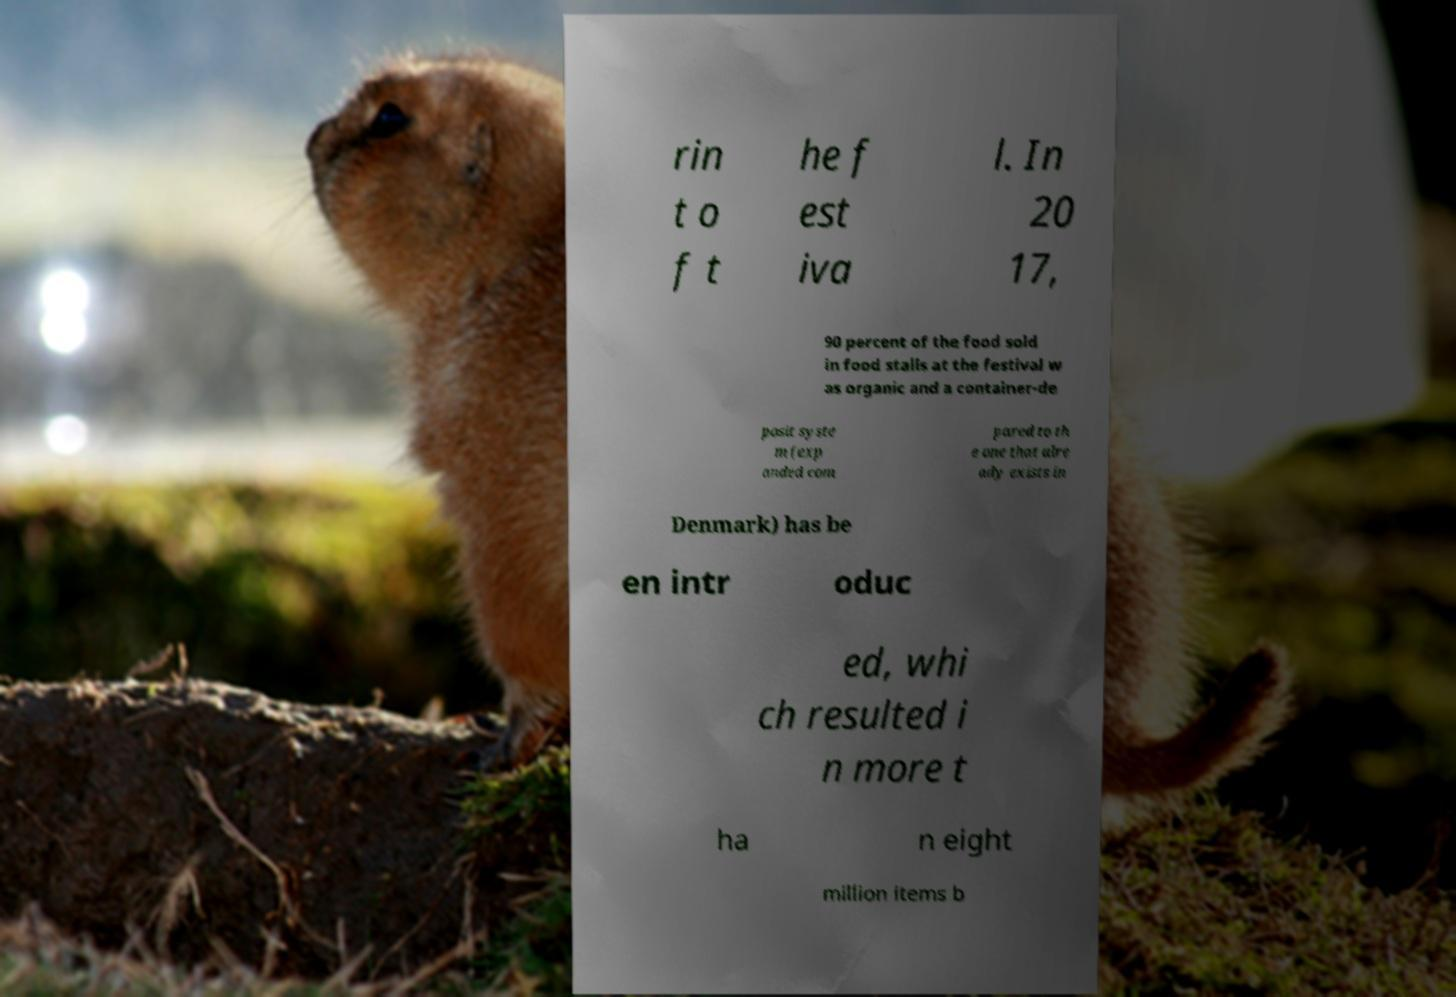There's text embedded in this image that I need extracted. Can you transcribe it verbatim? rin t o f t he f est iva l. In 20 17, 90 percent of the food sold in food stalls at the festival w as organic and a container-de posit syste m (exp anded com pared to th e one that alre ady exists in Denmark) has be en intr oduc ed, whi ch resulted i n more t ha n eight million items b 